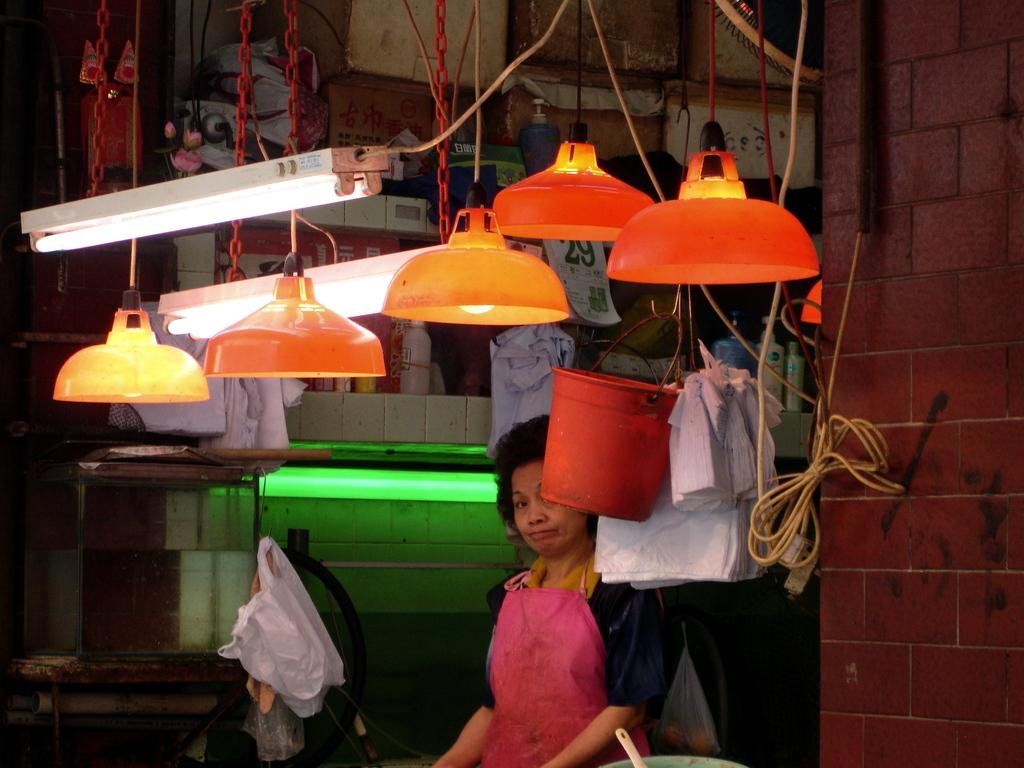What can be seen in the image related to a person? There is a person in the image. What is the person wearing? The person is wearing a pink color apron. What can be seen in the image related to lighting? There are lights in the image. What is the background of the image made of? There is a wall in the image. What is present in the image that might be related to electrical wiring? There are wires in the image. What is present in the image that might be used for covering or insulation? There are covers in the image. What other objects can be seen in the image? There are additional objects in the image. How many oranges are being used to decorate the wall in the image? There are no oranges present in the image. What type of oven can be seen in the image? There is no oven present in the image. 